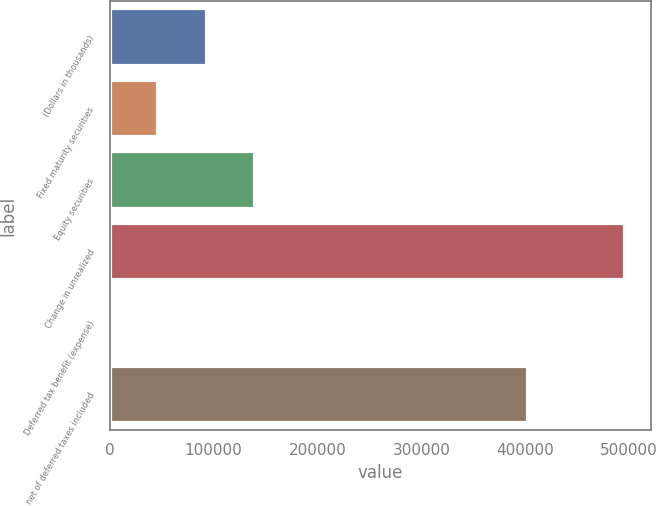<chart> <loc_0><loc_0><loc_500><loc_500><bar_chart><fcel>(Dollars in thousands)<fcel>Fixed maturity securities<fcel>Equity securities<fcel>Change in unrealized<fcel>Deferred tax benefit (expense)<fcel>net of deferred taxes included<nl><fcel>93543.8<fcel>46841.9<fcel>140246<fcel>496178<fcel>140<fcel>402774<nl></chart> 